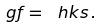Convert formula to latex. <formula><loc_0><loc_0><loc_500><loc_500>\ g f = \ h k s \, .</formula> 